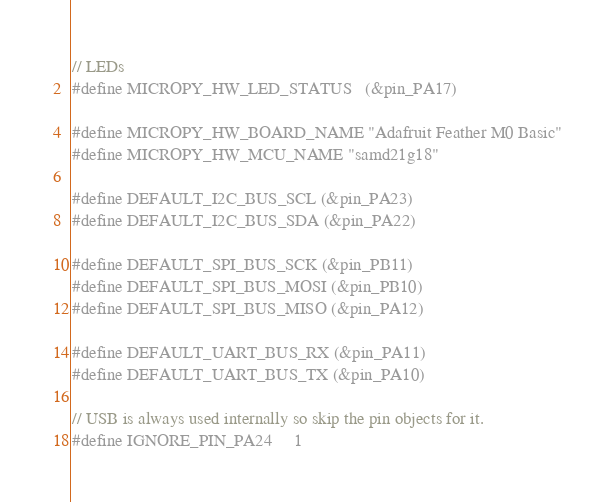Convert code to text. <code><loc_0><loc_0><loc_500><loc_500><_C_>// LEDs
#define MICROPY_HW_LED_STATUS   (&pin_PA17)

#define MICROPY_HW_BOARD_NAME "Adafruit Feather M0 Basic"
#define MICROPY_HW_MCU_NAME "samd21g18"

#define DEFAULT_I2C_BUS_SCL (&pin_PA23)
#define DEFAULT_I2C_BUS_SDA (&pin_PA22)

#define DEFAULT_SPI_BUS_SCK (&pin_PB11)
#define DEFAULT_SPI_BUS_MOSI (&pin_PB10)
#define DEFAULT_SPI_BUS_MISO (&pin_PA12)

#define DEFAULT_UART_BUS_RX (&pin_PA11)
#define DEFAULT_UART_BUS_TX (&pin_PA10)

// USB is always used internally so skip the pin objects for it.
#define IGNORE_PIN_PA24     1</code> 